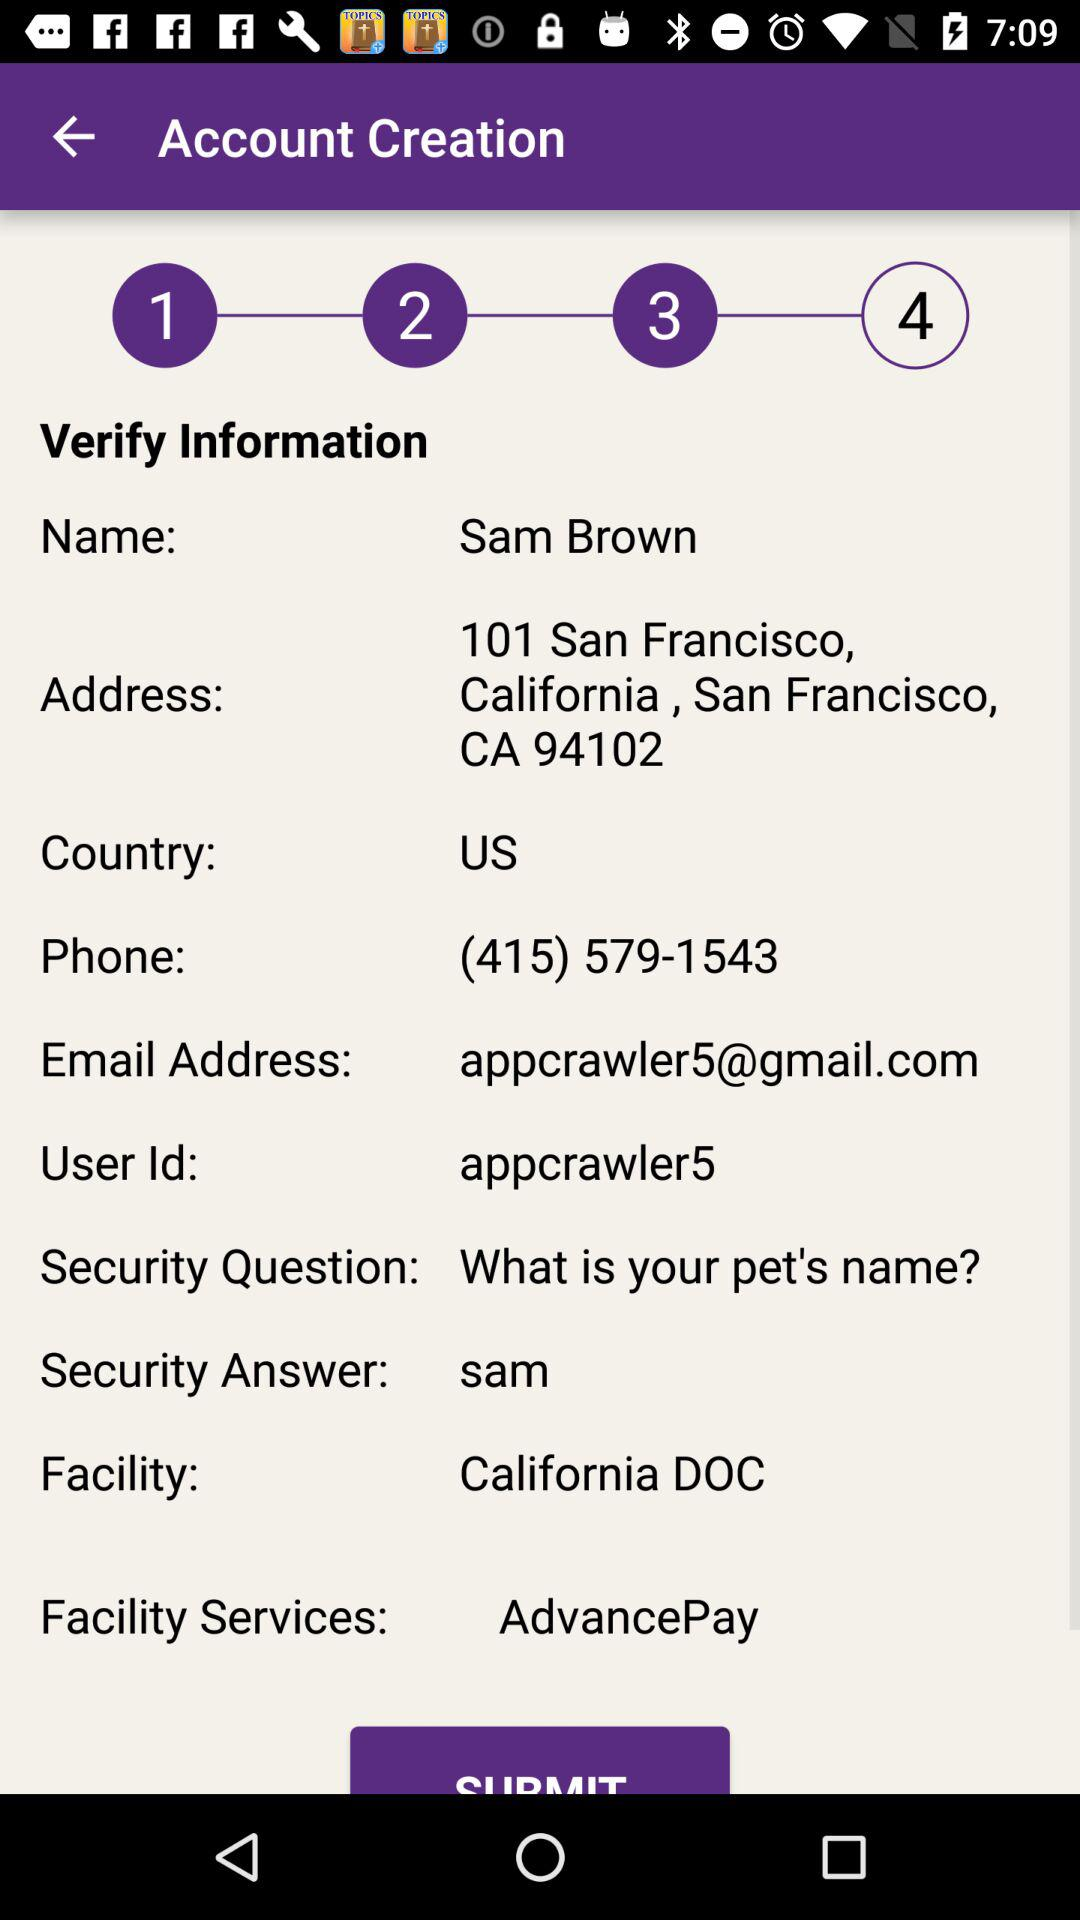What is the user ID of Sam? The user ID is "appcrawler5". 